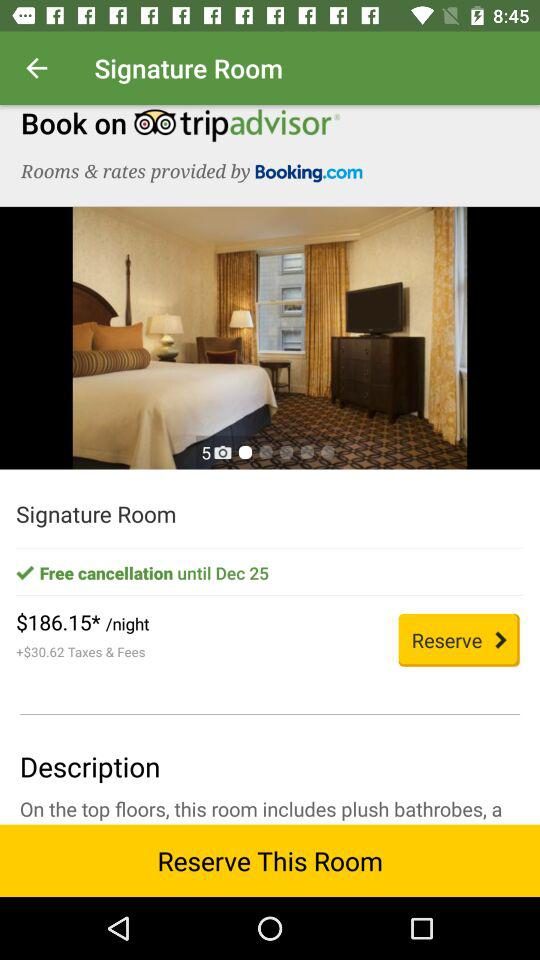When does the free cancellation period end? The free cancellation period ends on December 25. 